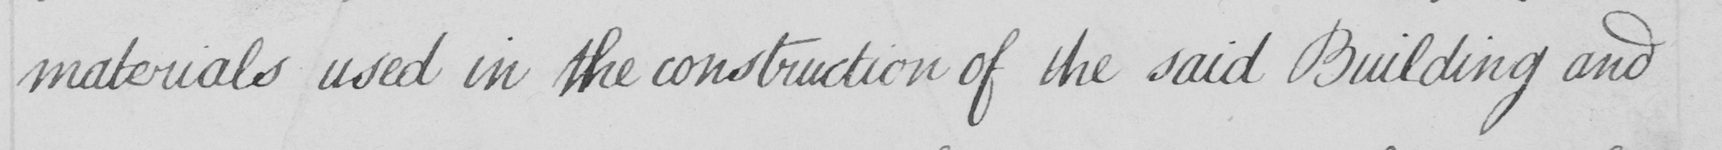Please provide the text content of this handwritten line. materials used in the construction of the said Building and 